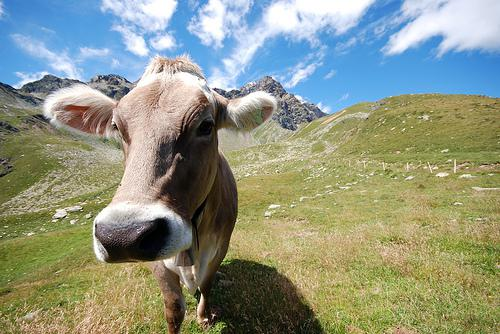Question: who milks the cow?
Choices:
A. Farmer.
B. Neighbor.
C. Child.
D. Businessman.
Answer with the letter. Answer: A Question: where are the cows ears?
Choices:
A. On her head.
B. In the grass.
C. On the halter.
D. In the bucket.
Answer with the letter. Answer: A Question: what is on the horizon?
Choices:
A. Mountains.
B. Beach.
C. Clouds.
D. Trees.
Answer with the letter. Answer: A Question: what is in the sky?
Choices:
A. Planes.
B. Clouds.
C. Kites.
D. Birds.
Answer with the letter. Answer: B 